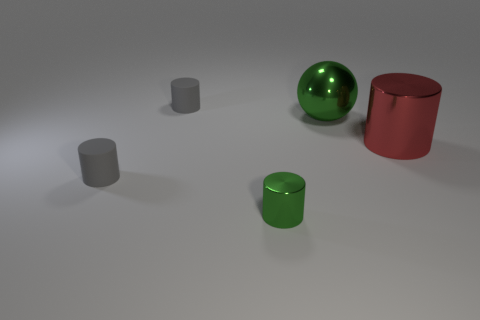Is there anything else that has the same shape as the large green metal object?
Offer a terse response. No. What number of things are the same color as the sphere?
Provide a succinct answer. 1. There is a big thing that is behind the large red object; is its color the same as the tiny shiny object?
Your answer should be very brief. Yes. Does the metallic sphere have the same color as the tiny metallic cylinder?
Your response must be concise. Yes. The green thing that is behind the gray cylinder that is to the left of the tiny object that is behind the metal ball is what shape?
Your answer should be very brief. Sphere. Is the number of tiny shiny objects behind the green cylinder less than the number of small gray cylinders right of the green metallic ball?
Provide a short and direct response. No. Do the gray thing that is in front of the green metallic sphere and the green shiny object that is on the right side of the tiny green thing have the same shape?
Provide a succinct answer. No. There is a green metallic object that is to the right of the green object that is left of the big sphere; what is its shape?
Provide a succinct answer. Sphere. The thing that is the same color as the small metallic cylinder is what size?
Make the answer very short. Large. Is there a big ball made of the same material as the tiny green cylinder?
Your answer should be compact. Yes. 